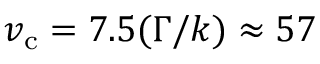<formula> <loc_0><loc_0><loc_500><loc_500>v _ { c } = 7 . 5 ( \Gamma / k ) \approx 5 7</formula> 